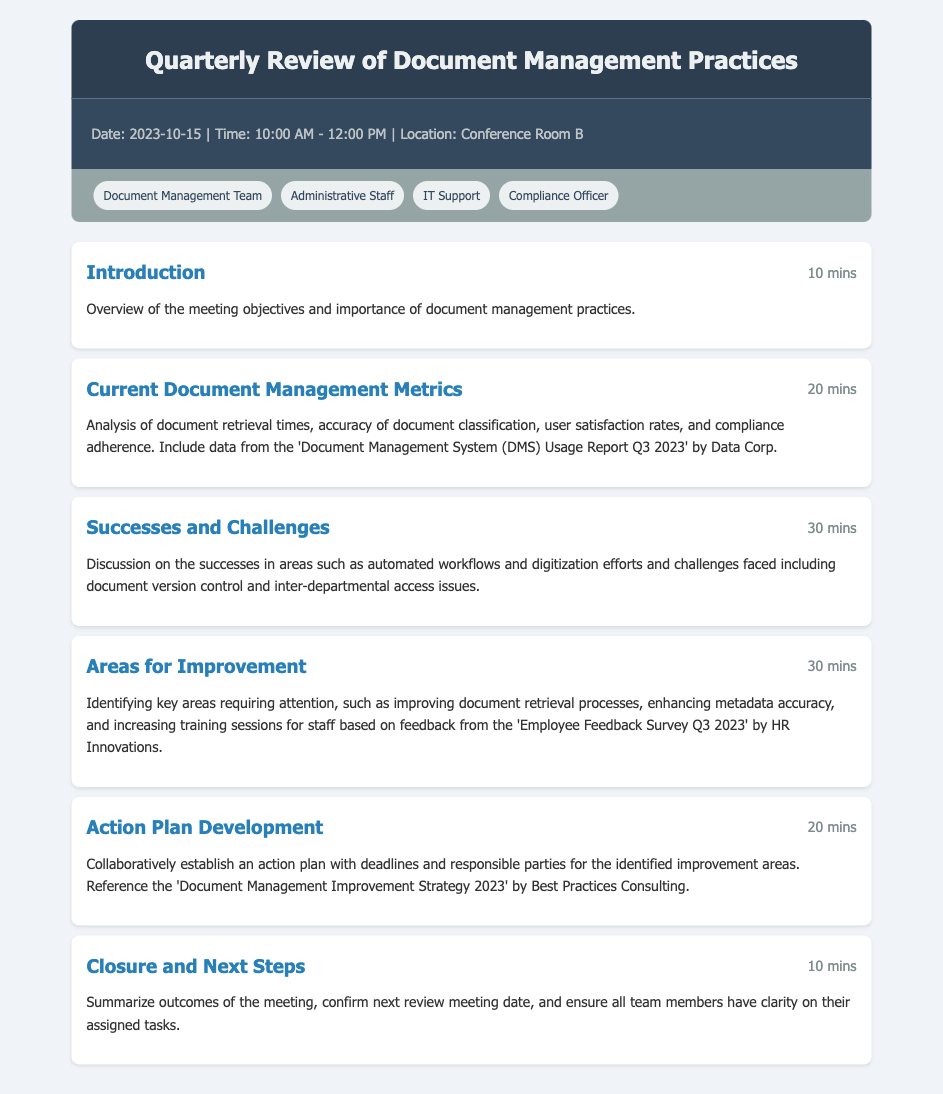What is the date of the meeting? The date of the meeting is specified in the meta-info section of the document.
Answer: 2023-10-15 What is the duration of the "Current Document Management Metrics" agenda item? The duration is indicated directly next to the agenda item title.
Answer: 20 mins Who are the participants listed in the document? Participants' names are listed in the participants section, typically showing the teams involved.
Answer: Document Management Team, Administrative Staff, IT Support, Compliance Officer What is one key area identified for improvement? Referring to the details of the "Areas for Improvement" agenda item highlights specific needs.
Answer: Improving document retrieval processes How long is allocated for the "Successes and Challenges" discussion? The duration is mentioned next to the agenda item title.
Answer: 30 mins What is the purpose of the "Action Plan Development" agenda item? The purpose is described in the details section for that agenda item.
Answer: Collaboratively establish an action plan with deadlines and responsible parties What will be summarized in the "Closure and Next Steps"? The closure section mentions a recap of the meeting outcomes.
Answer: Outcomes of the meeting What document is referenced for the "Current Document Management Metrics"? The source of the metrics data is provided in the agenda item details.
Answer: Document Management System (DMS) Usage Report Q3 2023 What is the time range for the meeting? The time of the meeting is found in the meta-info section.
Answer: 10:00 AM - 12:00 PM 